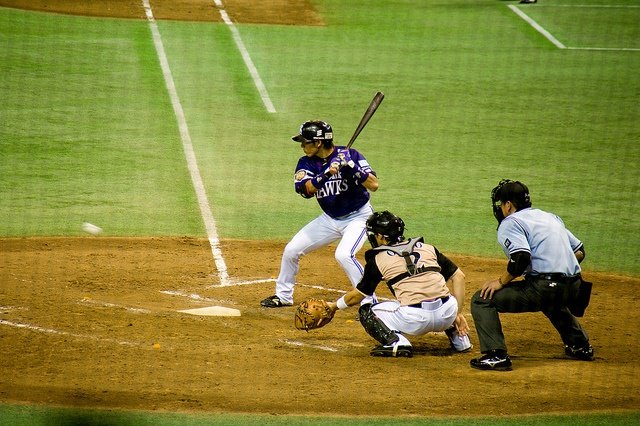Describe the objects in this image and their specific colors. I can see people in olive, black, lightgray, and darkgray tones, people in olive, black, lightgray, and tan tones, people in olive, lightgray, black, and darkgray tones, baseball glove in olive, black, and orange tones, and baseball bat in olive, black, and gray tones in this image. 